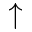Convert formula to latex. <formula><loc_0><loc_0><loc_500><loc_500>\uparrow</formula> 